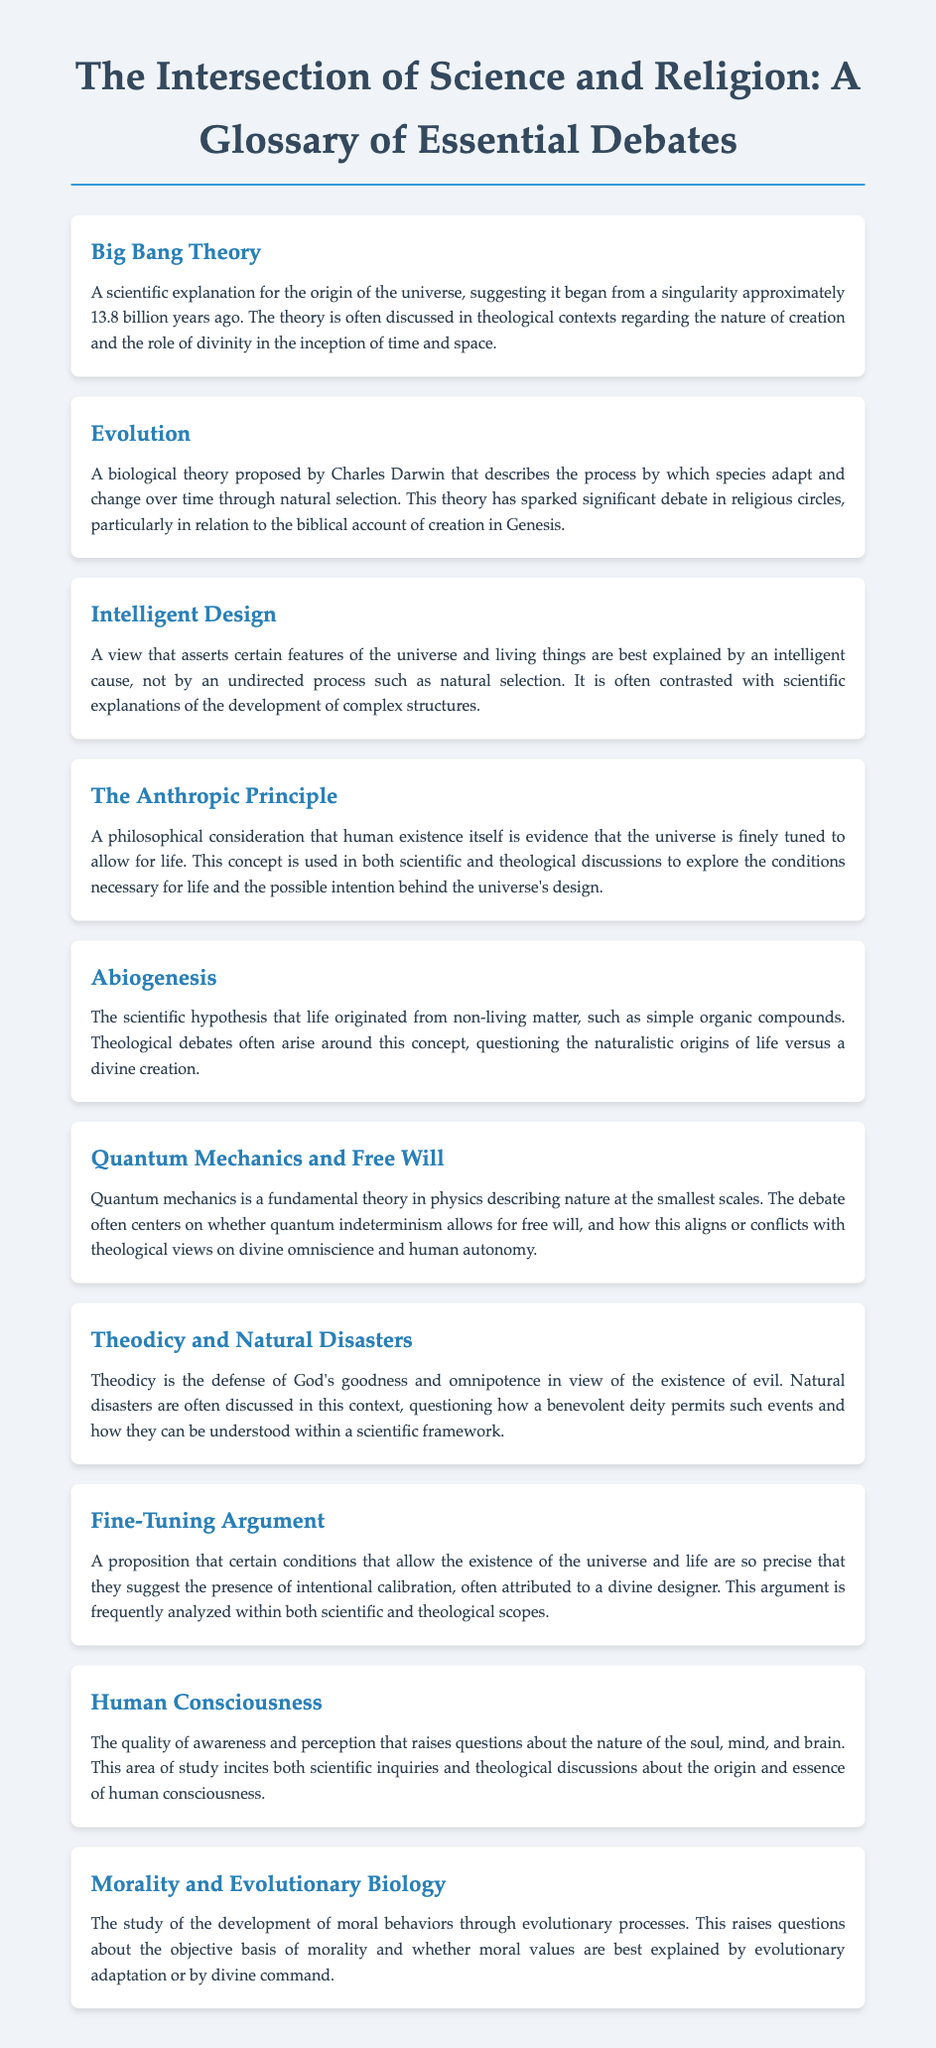What is the origin of the universe according to the Big Bang Theory? The Big Bang Theory suggests the universe began from a singularity approximately 13.8 billion years ago.
Answer: singularity approximately 13.8 billion years ago Who proposed the theory of evolution? The theory of evolution was proposed by Charles Darwin.
Answer: Charles Darwin What does the Anthropic Principle suggest? The Anthropic Principle suggests that human existence itself is evidence that the universe is finely tuned to allow for life.
Answer: finely tuned to allow for life What is the central idea of Intelligent Design? Intelligent Design asserts certain features of the universe and living things are best explained by an intelligent cause.
Answer: intelligent cause How does quantum mechanics relate to free will? Quantum mechanics raises a debate on whether quantum indeterminism allows for free will, conflicting with theological views on divine omniscience.
Answer: quantum indeterminism allows for free will What are natural disasters discussed in the context of? Natural disasters are discussed in the context of theodicy and the existence of evil.
Answer: theodicy and the existence of evil What is the focus of the discussion on morality and evolutionary biology? The discussion focuses on the development of moral behaviors through evolutionary processes.
Answer: development of moral behaviors Which hypothesis explains the origin of life from non-living matter? Abiogenesis is the scientific hypothesis that explains life originated from non-living matter.
Answer: Abiogenesis What is the Fine-Tuning Argument? The Fine-Tuning Argument suggests certain conditions that allow the existence of the universe and life imply intentional calibration.
Answer: intentional calibration 